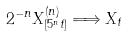<formula> <loc_0><loc_0><loc_500><loc_500>2 ^ { - n } X _ { [ 5 ^ { n } t ] } ^ { ( n ) } \Longrightarrow X _ { t }</formula> 